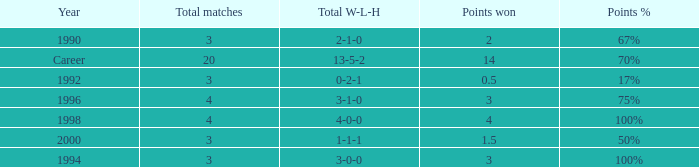Can you tell me the lowest Points won that has the Total matches of 4, and the Total W-L-H of 4-0-0? 4.0. 